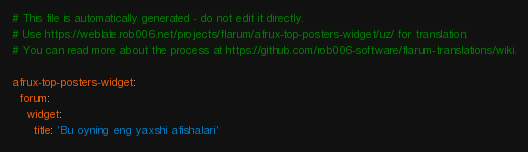<code> <loc_0><loc_0><loc_500><loc_500><_YAML_># This file is automatically generated - do not edit it directly.
# Use https://weblate.rob006.net/projects/flarum/afrux-top-posters-widget/uz/ for translation.
# You can read more about the process at https://github.com/rob006-software/flarum-translations/wiki.

afrux-top-posters-widget:
  forum:
    widget:
      title: 'Bu oyning eng yaxshi afishalari'
</code> 